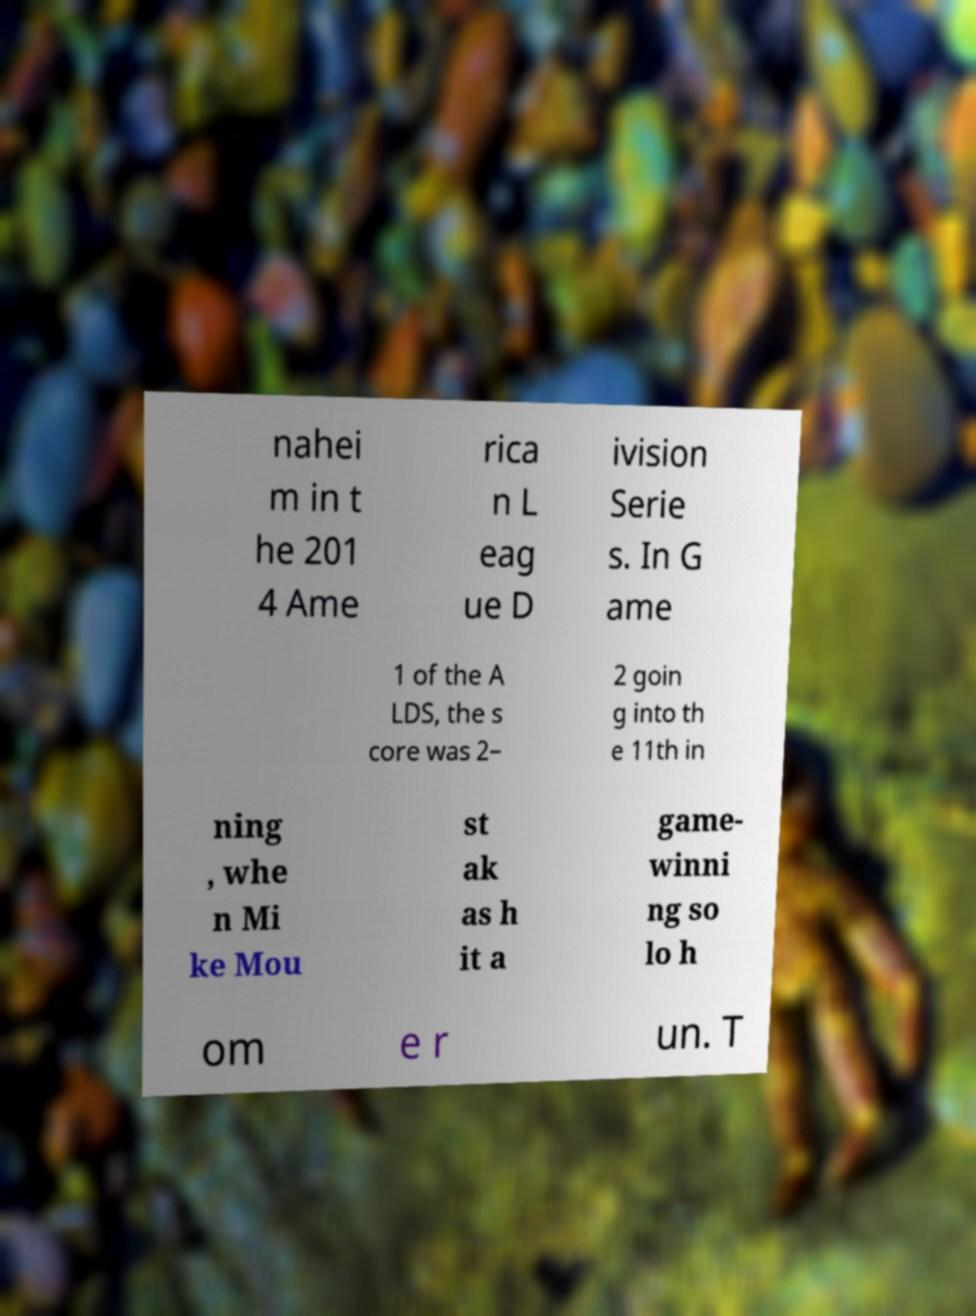For documentation purposes, I need the text within this image transcribed. Could you provide that? nahei m in t he 201 4 Ame rica n L eag ue D ivision Serie s. In G ame 1 of the A LDS, the s core was 2– 2 goin g into th e 11th in ning , whe n Mi ke Mou st ak as h it a game- winni ng so lo h om e r un. T 